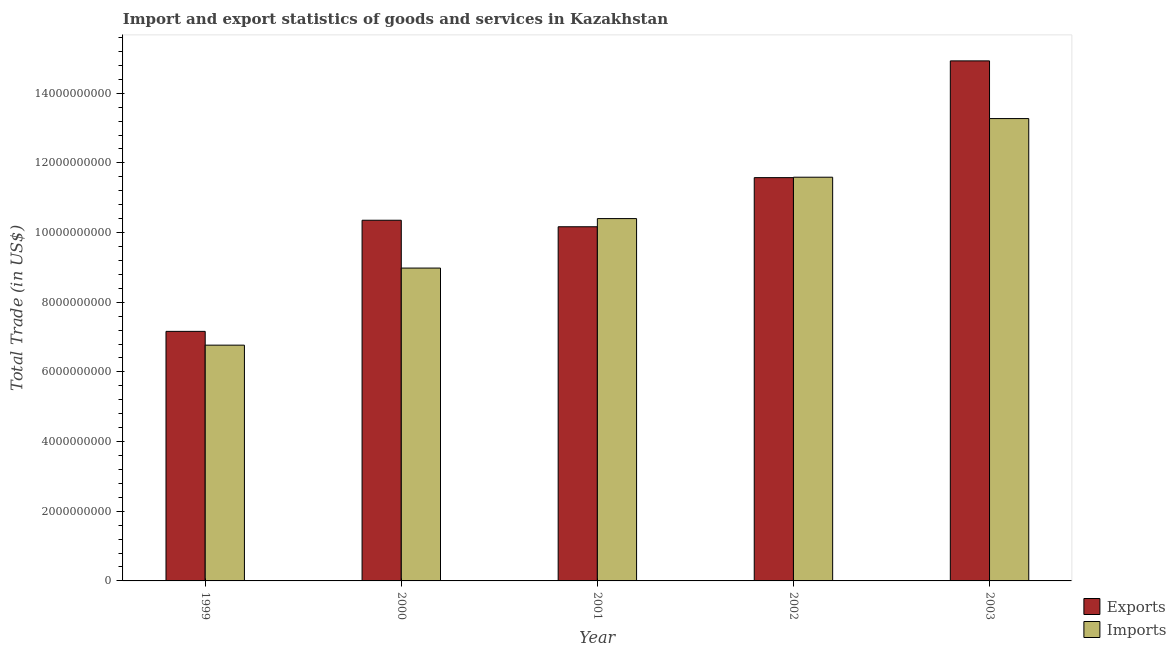How many groups of bars are there?
Give a very brief answer. 5. How many bars are there on the 5th tick from the left?
Make the answer very short. 2. What is the label of the 4th group of bars from the left?
Offer a terse response. 2002. What is the imports of goods and services in 1999?
Offer a very short reply. 6.77e+09. Across all years, what is the maximum export of goods and services?
Offer a very short reply. 1.49e+1. Across all years, what is the minimum imports of goods and services?
Give a very brief answer. 6.77e+09. In which year was the export of goods and services maximum?
Provide a short and direct response. 2003. In which year was the imports of goods and services minimum?
Offer a very short reply. 1999. What is the total imports of goods and services in the graph?
Your answer should be compact. 5.10e+1. What is the difference between the export of goods and services in 1999 and that in 2003?
Give a very brief answer. -7.77e+09. What is the difference between the imports of goods and services in 2001 and the export of goods and services in 2002?
Your answer should be compact. -1.19e+09. What is the average imports of goods and services per year?
Give a very brief answer. 1.02e+1. In how many years, is the export of goods and services greater than 400000000 US$?
Provide a short and direct response. 5. What is the ratio of the imports of goods and services in 2002 to that in 2003?
Provide a short and direct response. 0.87. Is the difference between the export of goods and services in 2002 and 2003 greater than the difference between the imports of goods and services in 2002 and 2003?
Offer a very short reply. No. What is the difference between the highest and the second highest imports of goods and services?
Give a very brief answer. 1.68e+09. What is the difference between the highest and the lowest export of goods and services?
Your response must be concise. 7.77e+09. Is the sum of the export of goods and services in 2000 and 2003 greater than the maximum imports of goods and services across all years?
Your answer should be compact. Yes. What does the 1st bar from the left in 2002 represents?
Your answer should be compact. Exports. What does the 1st bar from the right in 2002 represents?
Your answer should be very brief. Imports. How many bars are there?
Provide a short and direct response. 10. Are all the bars in the graph horizontal?
Ensure brevity in your answer.  No. How many years are there in the graph?
Ensure brevity in your answer.  5. What is the difference between two consecutive major ticks on the Y-axis?
Make the answer very short. 2.00e+09. Are the values on the major ticks of Y-axis written in scientific E-notation?
Provide a succinct answer. No. Does the graph contain any zero values?
Provide a succinct answer. No. Does the graph contain grids?
Give a very brief answer. No. Where does the legend appear in the graph?
Your answer should be very brief. Bottom right. What is the title of the graph?
Your answer should be very brief. Import and export statistics of goods and services in Kazakhstan. What is the label or title of the X-axis?
Offer a very short reply. Year. What is the label or title of the Y-axis?
Ensure brevity in your answer.  Total Trade (in US$). What is the Total Trade (in US$) in Exports in 1999?
Provide a succinct answer. 7.16e+09. What is the Total Trade (in US$) in Imports in 1999?
Provide a succinct answer. 6.77e+09. What is the Total Trade (in US$) of Exports in 2000?
Keep it short and to the point. 1.04e+1. What is the Total Trade (in US$) in Imports in 2000?
Make the answer very short. 8.98e+09. What is the Total Trade (in US$) of Exports in 2001?
Offer a terse response. 1.02e+1. What is the Total Trade (in US$) of Imports in 2001?
Make the answer very short. 1.04e+1. What is the Total Trade (in US$) of Exports in 2002?
Your answer should be very brief. 1.16e+1. What is the Total Trade (in US$) of Imports in 2002?
Provide a succinct answer. 1.16e+1. What is the Total Trade (in US$) of Exports in 2003?
Offer a very short reply. 1.49e+1. What is the Total Trade (in US$) of Imports in 2003?
Your answer should be compact. 1.33e+1. Across all years, what is the maximum Total Trade (in US$) of Exports?
Your answer should be very brief. 1.49e+1. Across all years, what is the maximum Total Trade (in US$) of Imports?
Ensure brevity in your answer.  1.33e+1. Across all years, what is the minimum Total Trade (in US$) of Exports?
Offer a very short reply. 7.16e+09. Across all years, what is the minimum Total Trade (in US$) in Imports?
Offer a very short reply. 6.77e+09. What is the total Total Trade (in US$) of Exports in the graph?
Provide a succinct answer. 5.42e+1. What is the total Total Trade (in US$) of Imports in the graph?
Provide a succinct answer. 5.10e+1. What is the difference between the Total Trade (in US$) in Exports in 1999 and that in 2000?
Make the answer very short. -3.19e+09. What is the difference between the Total Trade (in US$) of Imports in 1999 and that in 2000?
Your response must be concise. -2.21e+09. What is the difference between the Total Trade (in US$) of Exports in 1999 and that in 2001?
Keep it short and to the point. -3.00e+09. What is the difference between the Total Trade (in US$) in Imports in 1999 and that in 2001?
Provide a succinct answer. -3.63e+09. What is the difference between the Total Trade (in US$) in Exports in 1999 and that in 2002?
Ensure brevity in your answer.  -4.41e+09. What is the difference between the Total Trade (in US$) in Imports in 1999 and that in 2002?
Make the answer very short. -4.82e+09. What is the difference between the Total Trade (in US$) in Exports in 1999 and that in 2003?
Your response must be concise. -7.77e+09. What is the difference between the Total Trade (in US$) in Imports in 1999 and that in 2003?
Your answer should be compact. -6.50e+09. What is the difference between the Total Trade (in US$) of Exports in 2000 and that in 2001?
Your answer should be compact. 1.87e+08. What is the difference between the Total Trade (in US$) in Imports in 2000 and that in 2001?
Your answer should be very brief. -1.42e+09. What is the difference between the Total Trade (in US$) in Exports in 2000 and that in 2002?
Provide a short and direct response. -1.22e+09. What is the difference between the Total Trade (in US$) in Imports in 2000 and that in 2002?
Ensure brevity in your answer.  -2.61e+09. What is the difference between the Total Trade (in US$) in Exports in 2000 and that in 2003?
Offer a very short reply. -4.58e+09. What is the difference between the Total Trade (in US$) in Imports in 2000 and that in 2003?
Your answer should be compact. -4.29e+09. What is the difference between the Total Trade (in US$) in Exports in 2001 and that in 2002?
Keep it short and to the point. -1.41e+09. What is the difference between the Total Trade (in US$) of Imports in 2001 and that in 2002?
Provide a short and direct response. -1.19e+09. What is the difference between the Total Trade (in US$) in Exports in 2001 and that in 2003?
Keep it short and to the point. -4.76e+09. What is the difference between the Total Trade (in US$) in Imports in 2001 and that in 2003?
Give a very brief answer. -2.87e+09. What is the difference between the Total Trade (in US$) in Exports in 2002 and that in 2003?
Offer a very short reply. -3.35e+09. What is the difference between the Total Trade (in US$) of Imports in 2002 and that in 2003?
Your answer should be very brief. -1.68e+09. What is the difference between the Total Trade (in US$) in Exports in 1999 and the Total Trade (in US$) in Imports in 2000?
Offer a very short reply. -1.82e+09. What is the difference between the Total Trade (in US$) in Exports in 1999 and the Total Trade (in US$) in Imports in 2001?
Offer a very short reply. -3.24e+09. What is the difference between the Total Trade (in US$) in Exports in 1999 and the Total Trade (in US$) in Imports in 2002?
Your answer should be compact. -4.43e+09. What is the difference between the Total Trade (in US$) in Exports in 1999 and the Total Trade (in US$) in Imports in 2003?
Provide a short and direct response. -6.11e+09. What is the difference between the Total Trade (in US$) of Exports in 2000 and the Total Trade (in US$) of Imports in 2001?
Your response must be concise. -4.79e+07. What is the difference between the Total Trade (in US$) of Exports in 2000 and the Total Trade (in US$) of Imports in 2002?
Offer a very short reply. -1.24e+09. What is the difference between the Total Trade (in US$) of Exports in 2000 and the Total Trade (in US$) of Imports in 2003?
Keep it short and to the point. -2.92e+09. What is the difference between the Total Trade (in US$) in Exports in 2001 and the Total Trade (in US$) in Imports in 2002?
Your answer should be compact. -1.42e+09. What is the difference between the Total Trade (in US$) of Exports in 2001 and the Total Trade (in US$) of Imports in 2003?
Give a very brief answer. -3.11e+09. What is the difference between the Total Trade (in US$) of Exports in 2002 and the Total Trade (in US$) of Imports in 2003?
Offer a terse response. -1.70e+09. What is the average Total Trade (in US$) of Exports per year?
Your response must be concise. 1.08e+1. What is the average Total Trade (in US$) of Imports per year?
Your response must be concise. 1.02e+1. In the year 1999, what is the difference between the Total Trade (in US$) of Exports and Total Trade (in US$) of Imports?
Provide a short and direct response. 3.96e+08. In the year 2000, what is the difference between the Total Trade (in US$) of Exports and Total Trade (in US$) of Imports?
Offer a terse response. 1.37e+09. In the year 2001, what is the difference between the Total Trade (in US$) of Exports and Total Trade (in US$) of Imports?
Ensure brevity in your answer.  -2.35e+08. In the year 2002, what is the difference between the Total Trade (in US$) of Exports and Total Trade (in US$) of Imports?
Give a very brief answer. -1.24e+07. In the year 2003, what is the difference between the Total Trade (in US$) of Exports and Total Trade (in US$) of Imports?
Provide a short and direct response. 1.66e+09. What is the ratio of the Total Trade (in US$) in Exports in 1999 to that in 2000?
Offer a very short reply. 0.69. What is the ratio of the Total Trade (in US$) of Imports in 1999 to that in 2000?
Ensure brevity in your answer.  0.75. What is the ratio of the Total Trade (in US$) of Exports in 1999 to that in 2001?
Provide a succinct answer. 0.7. What is the ratio of the Total Trade (in US$) in Imports in 1999 to that in 2001?
Your response must be concise. 0.65. What is the ratio of the Total Trade (in US$) in Exports in 1999 to that in 2002?
Your response must be concise. 0.62. What is the ratio of the Total Trade (in US$) in Imports in 1999 to that in 2002?
Ensure brevity in your answer.  0.58. What is the ratio of the Total Trade (in US$) in Exports in 1999 to that in 2003?
Give a very brief answer. 0.48. What is the ratio of the Total Trade (in US$) in Imports in 1999 to that in 2003?
Offer a very short reply. 0.51. What is the ratio of the Total Trade (in US$) of Exports in 2000 to that in 2001?
Your answer should be very brief. 1.02. What is the ratio of the Total Trade (in US$) in Imports in 2000 to that in 2001?
Your response must be concise. 0.86. What is the ratio of the Total Trade (in US$) of Exports in 2000 to that in 2002?
Make the answer very short. 0.89. What is the ratio of the Total Trade (in US$) in Imports in 2000 to that in 2002?
Offer a very short reply. 0.77. What is the ratio of the Total Trade (in US$) of Exports in 2000 to that in 2003?
Provide a succinct answer. 0.69. What is the ratio of the Total Trade (in US$) of Imports in 2000 to that in 2003?
Keep it short and to the point. 0.68. What is the ratio of the Total Trade (in US$) in Exports in 2001 to that in 2002?
Provide a short and direct response. 0.88. What is the ratio of the Total Trade (in US$) in Imports in 2001 to that in 2002?
Keep it short and to the point. 0.9. What is the ratio of the Total Trade (in US$) of Exports in 2001 to that in 2003?
Make the answer very short. 0.68. What is the ratio of the Total Trade (in US$) of Imports in 2001 to that in 2003?
Offer a terse response. 0.78. What is the ratio of the Total Trade (in US$) of Exports in 2002 to that in 2003?
Offer a very short reply. 0.78. What is the ratio of the Total Trade (in US$) in Imports in 2002 to that in 2003?
Give a very brief answer. 0.87. What is the difference between the highest and the second highest Total Trade (in US$) of Exports?
Provide a short and direct response. 3.35e+09. What is the difference between the highest and the second highest Total Trade (in US$) of Imports?
Offer a very short reply. 1.68e+09. What is the difference between the highest and the lowest Total Trade (in US$) of Exports?
Offer a very short reply. 7.77e+09. What is the difference between the highest and the lowest Total Trade (in US$) in Imports?
Offer a terse response. 6.50e+09. 